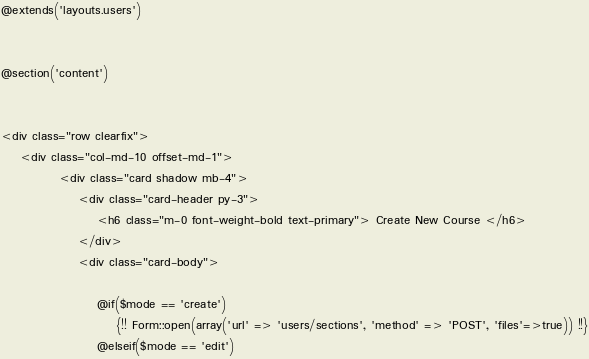Convert code to text. <code><loc_0><loc_0><loc_500><loc_500><_PHP_>@extends('layouts.users')


@section('content')


<div class="row clearfix">
    <div class="col-md-10 offset-md-1">
            <div class="card shadow mb-4">
                <div class="card-header py-3">
                    <h6 class="m-0 font-weight-bold text-primary"> Create New Course </h6>
                </div>
                <div class="card-body">

                    @if($mode == 'create')
                        {!! Form::open(array('url' => 'users/sections', 'method' => 'POST', 'files'=>true)) !!}
                    @elseif($mode == 'edit')</code> 